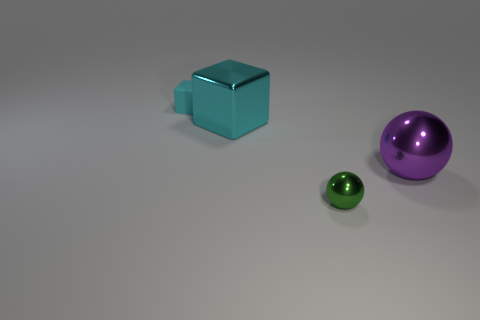Are there the same number of tiny objects that are in front of the small sphere and large green shiny objects?
Your answer should be very brief. Yes. Are there any other things that have the same size as the green ball?
Your response must be concise. Yes. What material is the small cyan thing that is the same shape as the large cyan object?
Make the answer very short. Rubber. The cyan thing that is behind the block that is to the right of the cyan rubber block is what shape?
Give a very brief answer. Cube. Are the large thing to the left of the purple object and the small green sphere made of the same material?
Provide a short and direct response. Yes. Are there the same number of tiny metallic spheres behind the tiny cyan object and green spheres that are in front of the green object?
Ensure brevity in your answer.  Yes. There is a thing that is the same color as the big block; what is it made of?
Your response must be concise. Rubber. What number of cyan blocks are in front of the object that is behind the cyan shiny block?
Make the answer very short. 1. There is a big shiny object to the left of the purple thing; is its color the same as the cube left of the large cyan shiny object?
Keep it short and to the point. Yes. What material is the cyan thing that is the same size as the purple shiny ball?
Provide a short and direct response. Metal. 